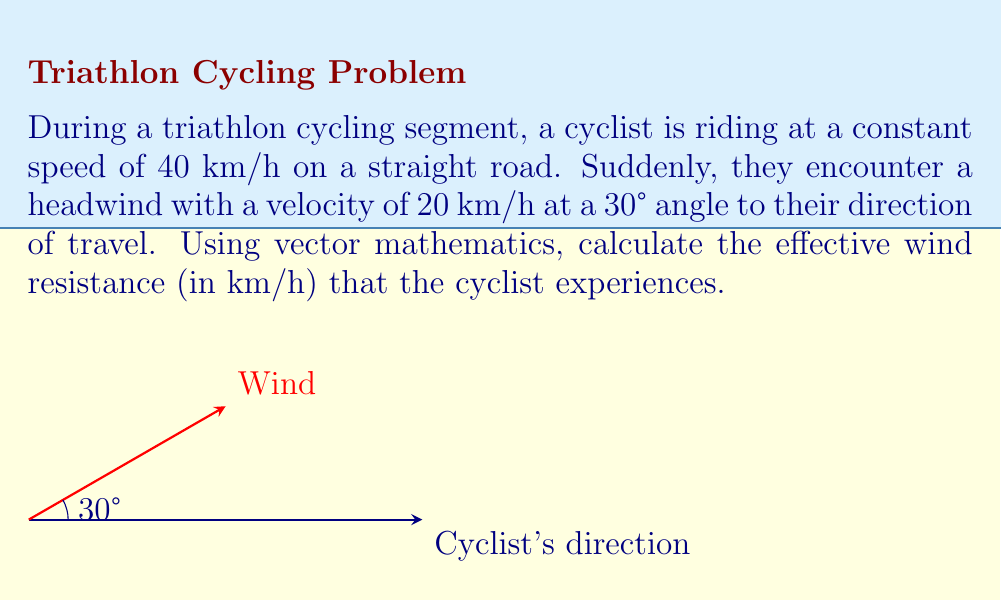Can you solve this math problem? Let's approach this step-by-step using vector mathematics:

1) First, we need to represent both velocities as vectors:
   - Cyclist's velocity: $\vec{v_c} = 40\hat{i}$ km/h
   - Wind velocity: $\vec{v_w} = 20(\cos 30°\hat{i} + \sin 30°\hat{j})$ km/h

2) The wind velocity components are:
   $\vec{v_w} = 20(\frac{\sqrt{3}}{2}\hat{i} + \frac{1}{2}\hat{j})$ km/h

3) The effective wind resistance is the component of the wind velocity that's parallel to the cyclist's direction of travel. We can find this using the dot product:

   $\vec{v_{eff}} = (\vec{v_w} \cdot \hat{i})\hat{i}$

4) Calculate the dot product:
   $\vec{v_w} \cdot \hat{i} = 20 \cdot \frac{\sqrt{3}}{2} = 10\sqrt{3}$ km/h

5) Therefore, the effective wind resistance vector is:
   $\vec{v_{eff}} = 10\sqrt{3}\hat{i}$ km/h

6) The magnitude of this vector is the scalar value of the effective wind resistance:
   $|\vec{v_{eff}}| = 10\sqrt{3} \approx 17.32$ km/h
Answer: $17.32$ km/h 